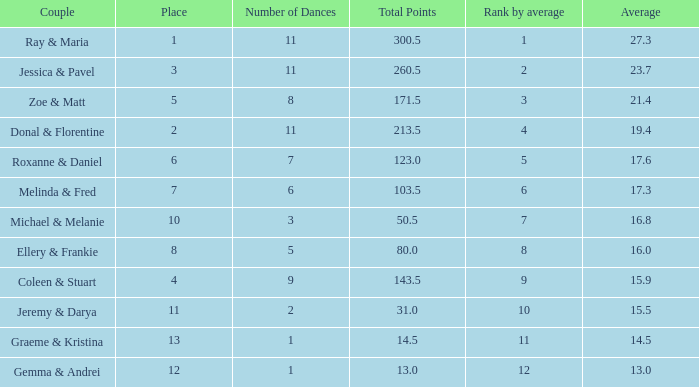If the total points is 50.5, what is the total number of dances? 1.0. 